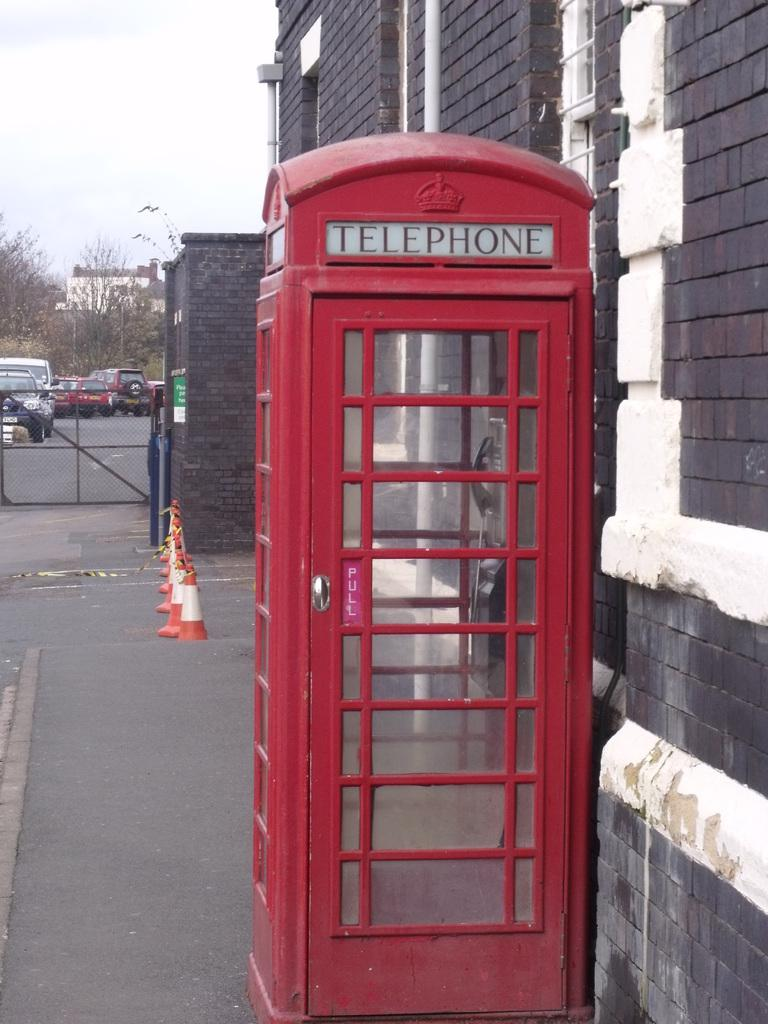<image>
Write a terse but informative summary of the picture. A red telephone booth on sidewalk in England 